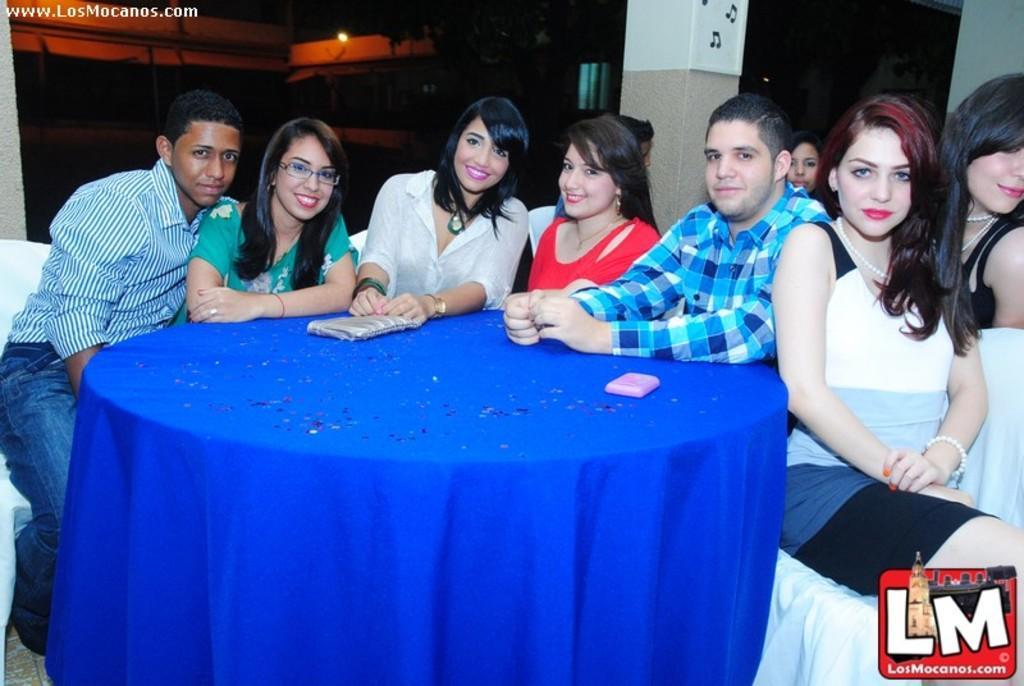Please provide a concise description of this image. In this image there is a table, on that table there is a blue cloth and there are two objects, around the table there are people sitting on chairs, in the top right there is a mirror and there is a reflection of a woman, in the background there is a pillar, in the top left there is text, in the bottom right there is a logo. 